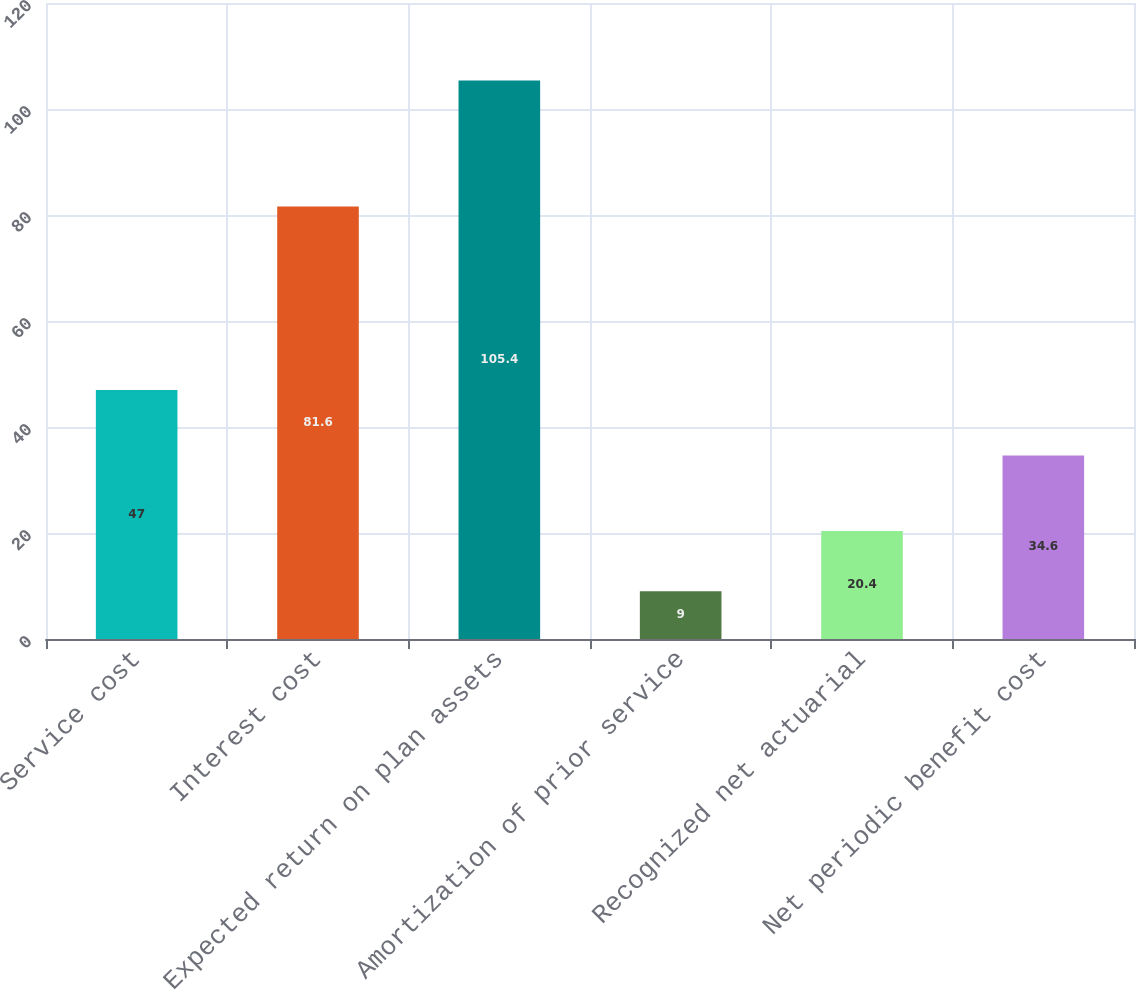Convert chart. <chart><loc_0><loc_0><loc_500><loc_500><bar_chart><fcel>Service cost<fcel>Interest cost<fcel>Expected return on plan assets<fcel>Amortization of prior service<fcel>Recognized net actuarial<fcel>Net periodic benefit cost<nl><fcel>47<fcel>81.6<fcel>105.4<fcel>9<fcel>20.4<fcel>34.6<nl></chart> 